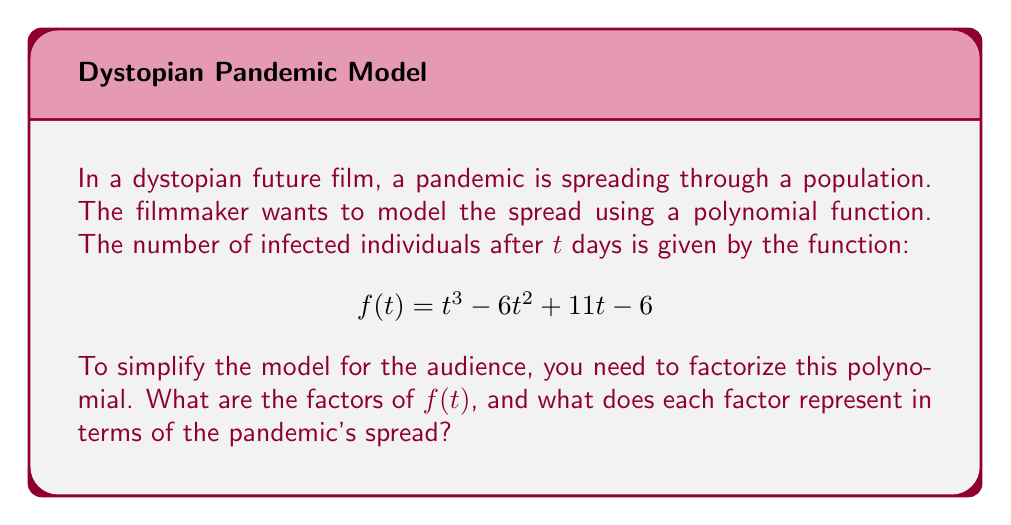Could you help me with this problem? To factorize the polynomial $f(t) = t^3 - 6t^2 + 11t - 6$, we'll follow these steps:

1) First, let's check if there are any rational roots using the rational root theorem. The possible rational roots are the factors of the constant term: ±1, ±2, ±3, ±6.

2) Testing these values, we find that $f(1) = 0$. So $(t-1)$ is a factor.

3) We can use polynomial long division to divide $f(t)$ by $(t-1)$:

   $$t^3 - 6t^2 + 11t - 6 = (t-1)(t^2 - 5t + 6)$$

4) Now we need to factorize $t^2 - 5t + 6$. This is a quadratic expression.

5) For a quadratic $ax^2 + bx + c$, we look for two numbers that multiply to give $ac$ and add to give $b$. Here, we need two numbers that multiply to give 6 and add to give -5.

6) These numbers are -2 and -3.

7) So, $t^2 - 5t + 6 = (t-2)(t-3)$

8) Putting it all together:

   $$f(t) = t^3 - 6t^2 + 11t - 6 = (t-1)(t-2)(t-3)$$

In terms of the pandemic's spread:
- $(t-1)$ suggests the infection starts spreading significantly 1 day after initial exposure.
- $(t-2)$ indicates a second phase or mutation occurring 2 days after initial exposure.
- $(t-3)$ points to a third phase or mutation 3 days after initial exposure.

This factorization allows the filmmaker to present a simplified model of the pandemic's progression, showing distinct phases or mutations occurring over the first three days.
Answer: $f(t) = (t-1)(t-2)(t-3)$ 